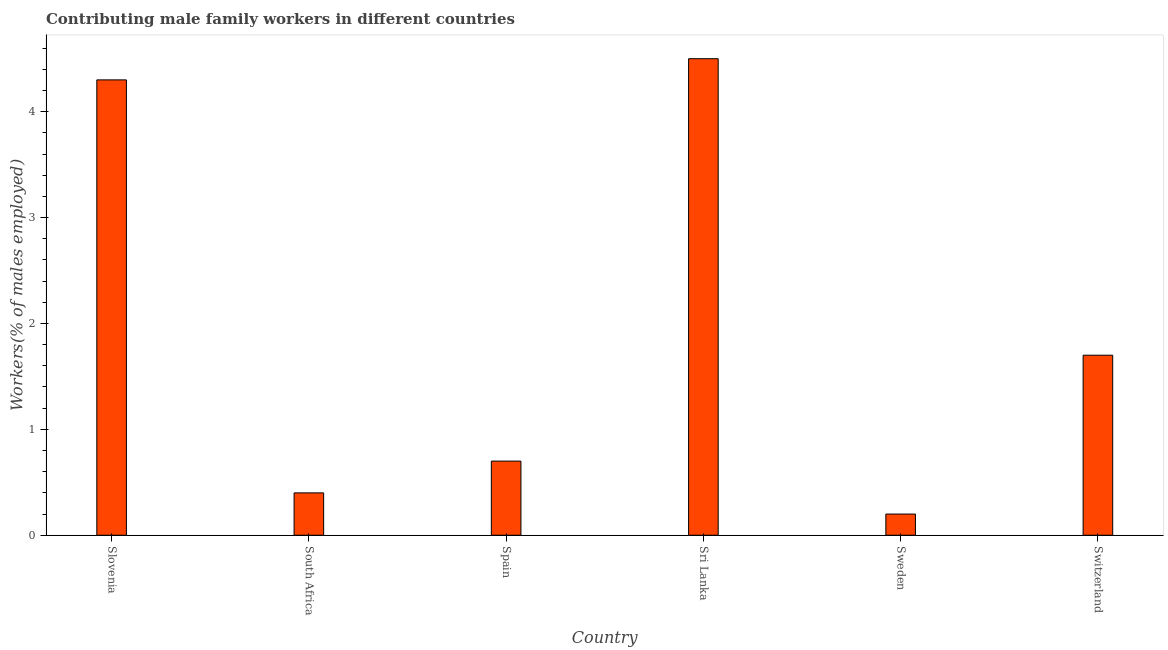Does the graph contain grids?
Provide a succinct answer. No. What is the title of the graph?
Your answer should be very brief. Contributing male family workers in different countries. What is the label or title of the Y-axis?
Make the answer very short. Workers(% of males employed). What is the contributing male family workers in South Africa?
Offer a very short reply. 0.4. Across all countries, what is the maximum contributing male family workers?
Keep it short and to the point. 4.5. Across all countries, what is the minimum contributing male family workers?
Make the answer very short. 0.2. In which country was the contributing male family workers maximum?
Offer a terse response. Sri Lanka. In which country was the contributing male family workers minimum?
Make the answer very short. Sweden. What is the sum of the contributing male family workers?
Offer a terse response. 11.8. What is the difference between the contributing male family workers in Slovenia and Sri Lanka?
Your answer should be very brief. -0.2. What is the average contributing male family workers per country?
Your response must be concise. 1.97. What is the median contributing male family workers?
Offer a very short reply. 1.2. What is the ratio of the contributing male family workers in South Africa to that in Spain?
Your response must be concise. 0.57. Is the difference between the contributing male family workers in Spain and Switzerland greater than the difference between any two countries?
Offer a very short reply. No. What is the difference between the highest and the lowest contributing male family workers?
Make the answer very short. 4.3. In how many countries, is the contributing male family workers greater than the average contributing male family workers taken over all countries?
Ensure brevity in your answer.  2. How many bars are there?
Make the answer very short. 6. Are all the bars in the graph horizontal?
Offer a terse response. No. Are the values on the major ticks of Y-axis written in scientific E-notation?
Offer a terse response. No. What is the Workers(% of males employed) of Slovenia?
Provide a short and direct response. 4.3. What is the Workers(% of males employed) of South Africa?
Offer a very short reply. 0.4. What is the Workers(% of males employed) in Spain?
Provide a short and direct response. 0.7. What is the Workers(% of males employed) of Sweden?
Provide a succinct answer. 0.2. What is the Workers(% of males employed) in Switzerland?
Your response must be concise. 1.7. What is the difference between the Workers(% of males employed) in Slovenia and South Africa?
Make the answer very short. 3.9. What is the difference between the Workers(% of males employed) in South Africa and Spain?
Offer a very short reply. -0.3. What is the difference between the Workers(% of males employed) in South Africa and Switzerland?
Your response must be concise. -1.3. What is the difference between the Workers(% of males employed) in Spain and Sri Lanka?
Offer a very short reply. -3.8. What is the difference between the Workers(% of males employed) in Spain and Sweden?
Provide a succinct answer. 0.5. What is the difference between the Workers(% of males employed) in Sri Lanka and Switzerland?
Keep it short and to the point. 2.8. What is the difference between the Workers(% of males employed) in Sweden and Switzerland?
Provide a succinct answer. -1.5. What is the ratio of the Workers(% of males employed) in Slovenia to that in South Africa?
Provide a short and direct response. 10.75. What is the ratio of the Workers(% of males employed) in Slovenia to that in Spain?
Provide a succinct answer. 6.14. What is the ratio of the Workers(% of males employed) in Slovenia to that in Sri Lanka?
Your response must be concise. 0.96. What is the ratio of the Workers(% of males employed) in Slovenia to that in Sweden?
Your response must be concise. 21.5. What is the ratio of the Workers(% of males employed) in Slovenia to that in Switzerland?
Make the answer very short. 2.53. What is the ratio of the Workers(% of males employed) in South Africa to that in Spain?
Offer a terse response. 0.57. What is the ratio of the Workers(% of males employed) in South Africa to that in Sri Lanka?
Offer a terse response. 0.09. What is the ratio of the Workers(% of males employed) in South Africa to that in Switzerland?
Your response must be concise. 0.23. What is the ratio of the Workers(% of males employed) in Spain to that in Sri Lanka?
Your answer should be very brief. 0.16. What is the ratio of the Workers(% of males employed) in Spain to that in Switzerland?
Offer a terse response. 0.41. What is the ratio of the Workers(% of males employed) in Sri Lanka to that in Sweden?
Your answer should be compact. 22.5. What is the ratio of the Workers(% of males employed) in Sri Lanka to that in Switzerland?
Offer a terse response. 2.65. What is the ratio of the Workers(% of males employed) in Sweden to that in Switzerland?
Your answer should be compact. 0.12. 